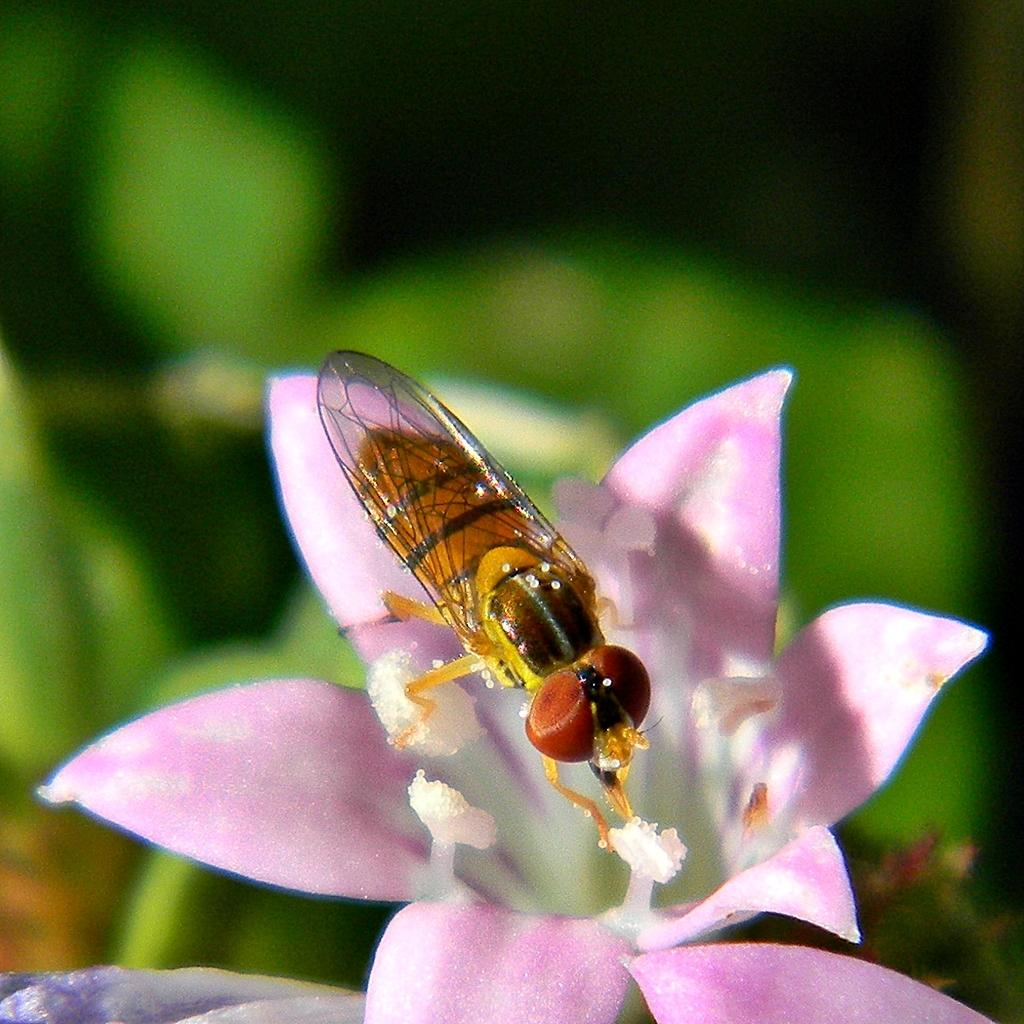What is present on the flower in the image? There is an insect on a flower in the image. Can you describe the insect's location on the flower? The insect is on a flower in the image. What can be observed about the background of the image? The background of the image is blurred. What are the insect's hobbies in the image? There is no information about the insect's hobbies in the image. Is there a tin can visible in the image? There is no tin can present in the image. 